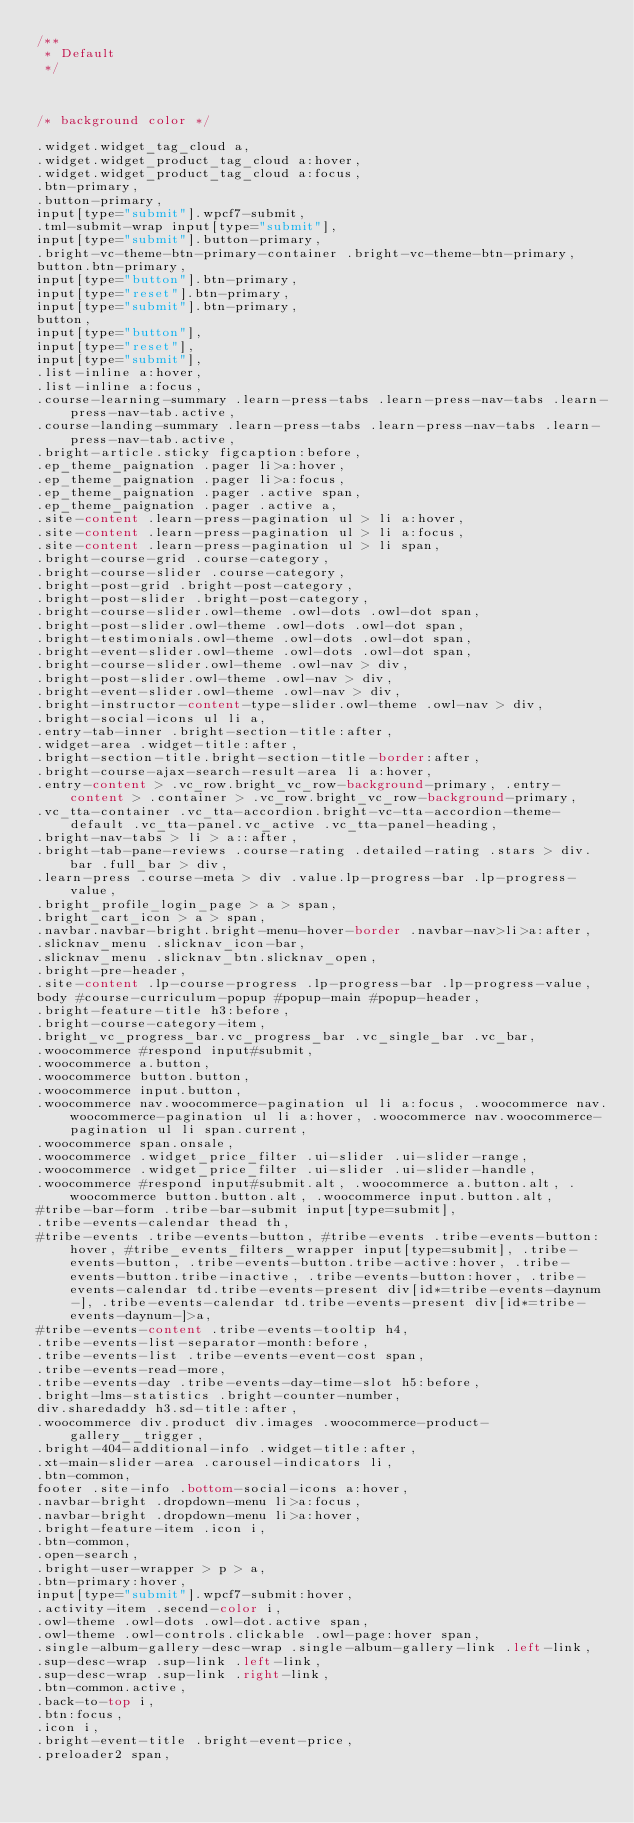<code> <loc_0><loc_0><loc_500><loc_500><_CSS_>/**
 * Default
 */



/* background color */

.widget.widget_tag_cloud a,
.widget.widget_product_tag_cloud a:hover,
.widget.widget_product_tag_cloud a:focus,
.btn-primary,
.button-primary,
input[type="submit"].wpcf7-submit,
.tml-submit-wrap input[type="submit"],
input[type="submit"].button-primary,
.bright-vc-theme-btn-primary-container .bright-vc-theme-btn-primary,
button.btn-primary, 
input[type="button"].btn-primary, 
input[type="reset"].btn-primary, 
input[type="submit"].btn-primary,
button, 
input[type="button"], 
input[type="reset"], 
input[type="submit"],
.list-inline a:hover,
.list-inline a:focus,
.course-learning-summary .learn-press-tabs .learn-press-nav-tabs .learn-press-nav-tab.active,
.course-landing-summary .learn-press-tabs .learn-press-nav-tabs .learn-press-nav-tab.active,
.bright-article.sticky figcaption:before,
.ep_theme_paignation .pager li>a:hover,
.ep_theme_paignation .pager li>a:focus,
.ep_theme_paignation .pager .active span,
.ep_theme_paignation .pager .active a,
.site-content .learn-press-pagination ul > li a:hover, 
.site-content .learn-press-pagination ul > li a:focus, 
.site-content .learn-press-pagination ul > li span,
.bright-course-grid .course-category, 
.bright-course-slider .course-category,
.bright-post-grid .bright-post-category, 
.bright-post-slider .bright-post-category,
.bright-course-slider.owl-theme .owl-dots .owl-dot span,
.bright-post-slider.owl-theme .owl-dots .owl-dot span,
.bright-testimonials.owl-theme .owl-dots .owl-dot span,
.bright-event-slider.owl-theme .owl-dots .owl-dot span,
.bright-course-slider.owl-theme .owl-nav > div,
.bright-post-slider.owl-theme .owl-nav > div,
.bright-event-slider.owl-theme .owl-nav > div,
.bright-instructor-content-type-slider.owl-theme .owl-nav > div,
.bright-social-icons ul li a,
.entry-tab-inner .bright-section-title:after,
.widget-area .widget-title:after,
.bright-section-title.bright-section-title-border:after,
.bright-course-ajax-search-result-area li a:hover,
.entry-content > .vc_row.bright_vc_row-background-primary, .entry-content > .container > .vc_row.bright_vc_row-background-primary,
.vc_tta-container .vc_tta-accordion.bright-vc-tta-accordion-theme-default .vc_tta-panel.vc_active .vc_tta-panel-heading,
.bright-nav-tabs > li > a::after,
.bright-tab-pane-reviews .course-rating .detailed-rating .stars > div.bar .full_bar > div,
.learn-press .course-meta > div .value.lp-progress-bar .lp-progress-value,
.bright_profile_login_page > a > span,
.bright_cart_icon > a > span,
.navbar.navbar-bright.bright-menu-hover-border .navbar-nav>li>a:after,
.slicknav_menu .slicknav_icon-bar,
.slicknav_menu .slicknav_btn.slicknav_open,
.bright-pre-header,
.site-content .lp-course-progress .lp-progress-bar .lp-progress-value,
body #course-curriculum-popup #popup-main #popup-header,
.bright-feature-title h3:before,
.bright-course-category-item,
.bright_vc_progress_bar.vc_progress_bar .vc_single_bar .vc_bar,
.woocommerce #respond input#submit, 
.woocommerce a.button, 
.woocommerce button.button, 
.woocommerce input.button,
.woocommerce nav.woocommerce-pagination ul li a:focus, .woocommerce nav.woocommerce-pagination ul li a:hover, .woocommerce nav.woocommerce-pagination ul li span.current,
.woocommerce span.onsale,
.woocommerce .widget_price_filter .ui-slider .ui-slider-range,
.woocommerce .widget_price_filter .ui-slider .ui-slider-handle,
.woocommerce #respond input#submit.alt, .woocommerce a.button.alt, .woocommerce button.button.alt, .woocommerce input.button.alt,
#tribe-bar-form .tribe-bar-submit input[type=submit],
.tribe-events-calendar thead th,
#tribe-events .tribe-events-button, #tribe-events .tribe-events-button:hover, #tribe_events_filters_wrapper input[type=submit], .tribe-events-button, .tribe-events-button.tribe-active:hover, .tribe-events-button.tribe-inactive, .tribe-events-button:hover, .tribe-events-calendar td.tribe-events-present div[id*=tribe-events-daynum-], .tribe-events-calendar td.tribe-events-present div[id*=tribe-events-daynum-]>a,
#tribe-events-content .tribe-events-tooltip h4,
.tribe-events-list-separator-month:before,
.tribe-events-list .tribe-events-event-cost span,
.tribe-events-read-more,
.tribe-events-day .tribe-events-day-time-slot h5:before,
.bright-lms-statistics .bright-counter-number,
div.sharedaddy h3.sd-title:after,
.woocommerce div.product div.images .woocommerce-product-gallery__trigger,
.bright-404-additional-info .widget-title:after,
.xt-main-slider-area .carousel-indicators li,
.btn-common,
footer .site-info .bottom-social-icons a:hover,
.navbar-bright .dropdown-menu li>a:focus, 
.navbar-bright .dropdown-menu li>a:hover,
.bright-feature-item .icon i,
.btn-common,
.open-search,
.bright-user-wrapper > p > a,
.btn-primary:hover,
input[type="submit"].wpcf7-submit:hover,
.activity-item .secend-color i,
.owl-theme .owl-dots .owl-dot.active span,
.owl-theme .owl-controls.clickable .owl-page:hover span,
.single-album-gallery-desc-wrap .single-album-gallery-link .left-link,
.sup-desc-wrap .sup-link .left-link,
.sup-desc-wrap .sup-link .right-link,
.btn-common.active,
.back-to-top i,
.btn:focus,
.icon i,
.bright-event-title .bright-event-price,
.preloader2 span,</code> 